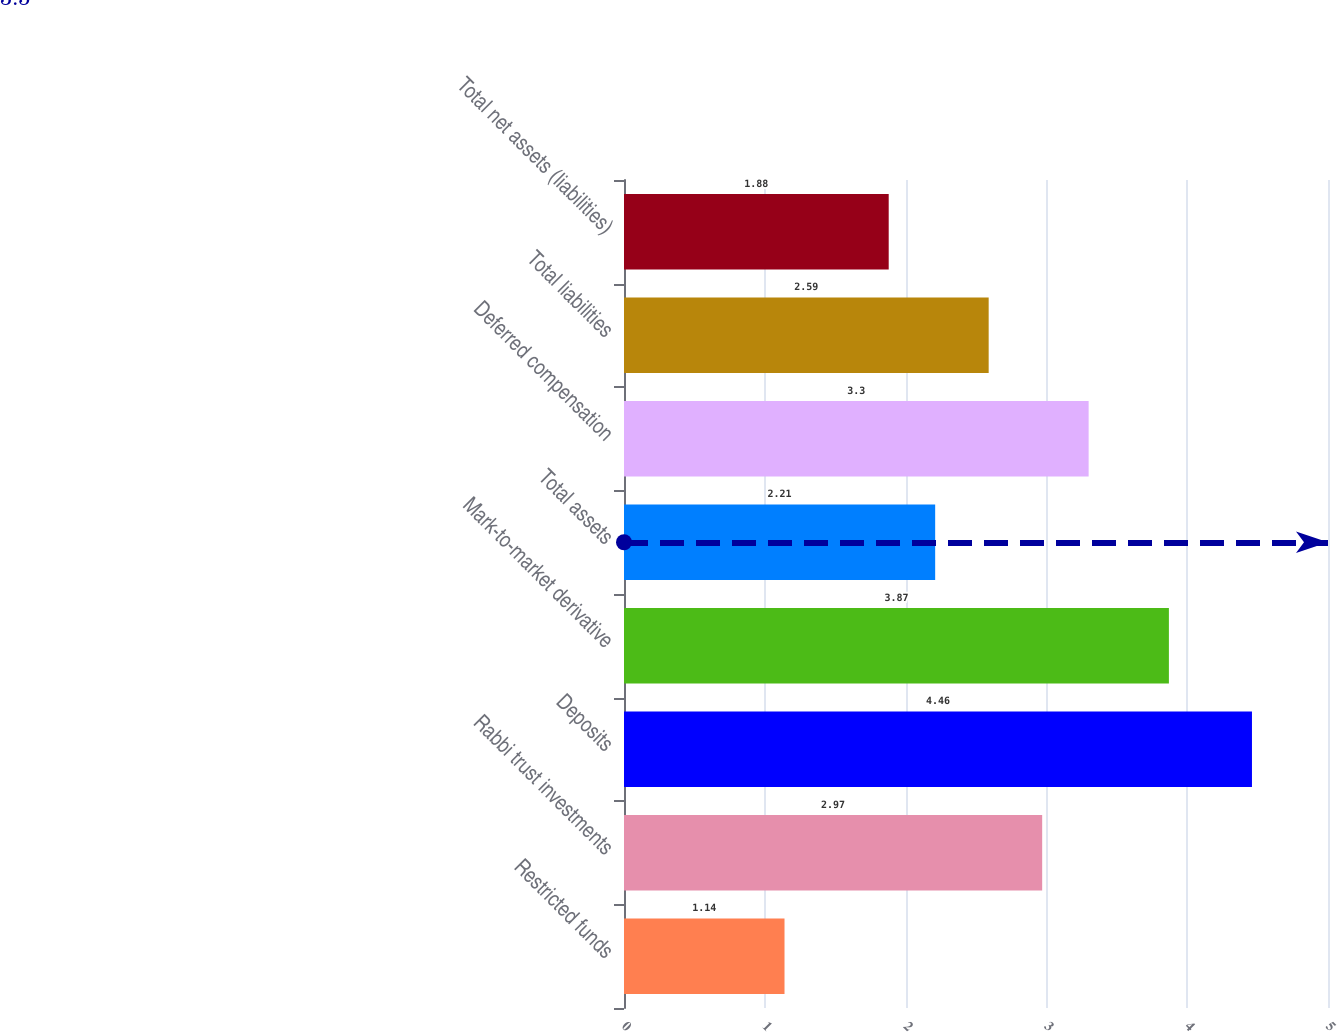<chart> <loc_0><loc_0><loc_500><loc_500><bar_chart><fcel>Restricted funds<fcel>Rabbi trust investments<fcel>Deposits<fcel>Mark-to-market derivative<fcel>Total assets<fcel>Deferred compensation<fcel>Total liabilities<fcel>Total net assets (liabilities)<nl><fcel>1.14<fcel>2.97<fcel>4.46<fcel>3.87<fcel>2.21<fcel>3.3<fcel>2.59<fcel>1.88<nl></chart> 